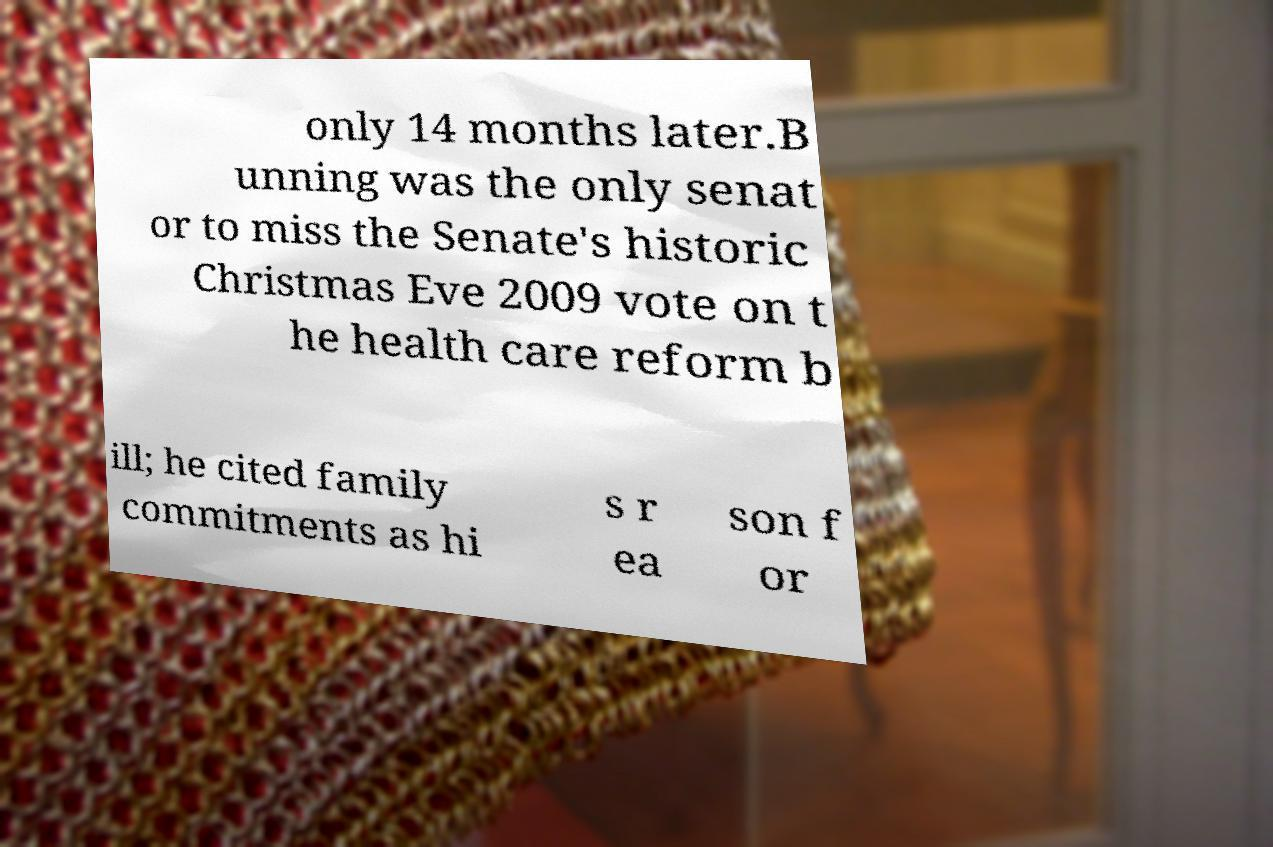Could you extract and type out the text from this image? only 14 months later.B unning was the only senat or to miss the Senate's historic Christmas Eve 2009 vote on t he health care reform b ill; he cited family commitments as hi s r ea son f or 